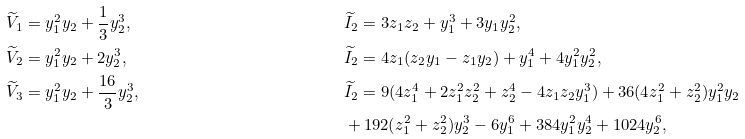<formula> <loc_0><loc_0><loc_500><loc_500>& \widetilde { V } _ { 1 } = y _ { 1 } ^ { 2 } y _ { 2 } + \frac { 1 } { 3 } y _ { 2 } ^ { 3 } , & & \widetilde { I } _ { 2 } = 3 z _ { 1 } z _ { 2 } + y _ { 1 } ^ { 3 } + 3 y _ { 1 } y _ { 2 } ^ { 2 } , \\ & \widetilde { V } _ { 2 } = y _ { 1 } ^ { 2 } y _ { 2 } + 2 y _ { 2 } ^ { 3 } , & & \widetilde { I } _ { 2 } = 4 z _ { 1 } ( z _ { 2 } y _ { 1 } - z _ { 1 } y _ { 2 } ) + y _ { 1 } ^ { 4 } + 4 y _ { 1 } ^ { 2 } y _ { 2 } ^ { 2 } , \\ & \widetilde { V } _ { 3 } = y _ { 1 } ^ { 2 } y _ { 2 } + \frac { 1 6 } { 3 } y _ { 2 } ^ { 3 } , & & \widetilde { I } _ { 2 } = 9 ( 4 z _ { 1 } ^ { 4 } + 2 z _ { 1 } ^ { 2 } z _ { 2 } ^ { 2 } + z _ { 2 } ^ { 4 } - 4 z _ { 1 } z _ { 2 } y _ { 1 } ^ { 3 } ) + 3 6 ( 4 z _ { 1 } ^ { 2 } + z _ { 2 } ^ { 2 } ) y _ { 1 } ^ { 2 } y _ { 2 } \\ & & & + 1 9 2 ( z _ { 1 } ^ { 2 } + z _ { 2 } ^ { 2 } ) y _ { 2 } ^ { 3 } - 6 y _ { 1 } ^ { 6 } + 3 8 4 y _ { 1 } ^ { 2 } y _ { 2 } ^ { 4 } + 1 0 2 4 y _ { 2 } ^ { 6 } ,</formula> 